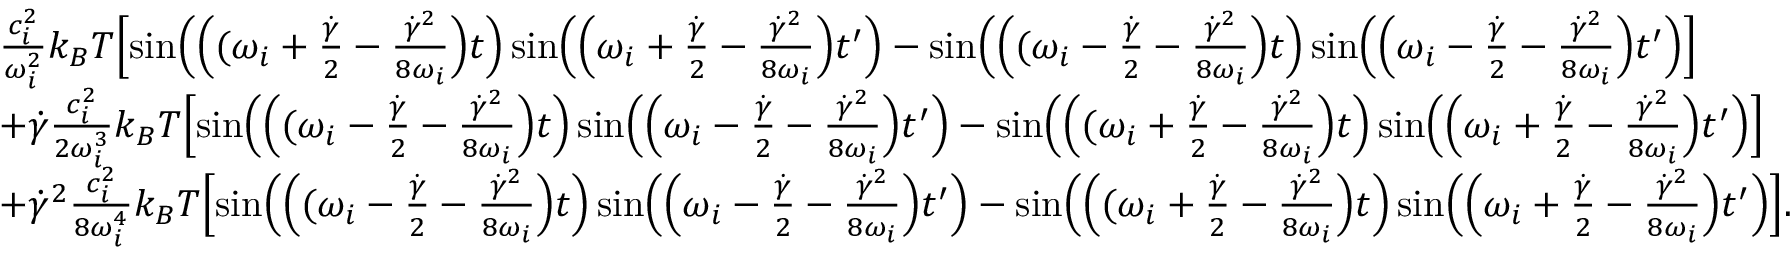<formula> <loc_0><loc_0><loc_500><loc_500>\begin{array} { r l } & { \frac { c _ { i } ^ { 2 } } { \omega _ { i } ^ { 2 } } k _ { B } T \left [ \sin \left ( \left ( ( \omega _ { i } + \frac { \dot { \gamma } } { 2 } - \frac { \dot { \gamma } ^ { 2 } } { 8 \omega _ { i } } \right ) t \right ) \sin \left ( \left ( \omega _ { i } + \frac { \dot { \gamma } } { 2 } - \frac { \dot { \gamma } ^ { 2 } } { 8 \omega _ { i } } \right ) t ^ { \prime } \right ) - \sin \left ( \left ( ( \omega _ { i } - \frac { \dot { \gamma } } { 2 } - \frac { \dot { \gamma } ^ { 2 } } { 8 \omega _ { i } } \right ) t \right ) \sin \left ( \left ( \omega _ { i } - \frac { \dot { \gamma } } { 2 } - \frac { \dot { \gamma } ^ { 2 } } { 8 \omega _ { i } } \right ) t ^ { \prime } \right ) \right ] } \\ & { + \dot { \gamma } \frac { c _ { i } ^ { 2 } } { 2 \omega _ { i } ^ { 3 } } k _ { B } T \left [ \sin \left ( \left ( ( \omega _ { i } - \frac { \dot { \gamma } } { 2 } - \frac { \dot { \gamma } ^ { 2 } } { 8 \omega _ { i } } \right ) t \right ) \sin \left ( \left ( \omega _ { i } - \frac { \dot { \gamma } } { 2 } - \frac { \dot { \gamma } ^ { 2 } } { 8 \omega _ { i } } \right ) t ^ { \prime } \right ) - \sin \left ( \left ( ( \omega _ { i } + \frac { \dot { \gamma } } { 2 } - \frac { \dot { \gamma } ^ { 2 } } { 8 \omega _ { i } } \right ) t \right ) \sin \left ( \left ( \omega _ { i } + \frac { \dot { \gamma } } { 2 } - \frac { \dot { \gamma } ^ { 2 } } { 8 \omega _ { i } } \right ) t ^ { \prime } \right ) \right ] } \\ & { + \dot { \gamma } ^ { 2 } \frac { c _ { i } ^ { 2 } } { 8 \omega _ { i } ^ { 4 } } k _ { B } T \left [ \sin \left ( \left ( ( \omega _ { i } - \frac { \dot { \gamma } } { 2 } - \frac { \dot { \gamma } ^ { 2 } } { 8 \omega _ { i } } \right ) t \right ) \sin \left ( \left ( \omega _ { i } - \frac { \dot { \gamma } } { 2 } - \frac { \dot { \gamma } ^ { 2 } } { 8 \omega _ { i } } \right ) t ^ { \prime } \right ) - \sin \left ( \left ( ( \omega _ { i } + \frac { \dot { \gamma } } { 2 } - \frac { \dot { \gamma } ^ { 2 } } { 8 \omega _ { i } } \right ) t \right ) \sin \left ( \left ( \omega _ { i } + \frac { \dot { \gamma } } { 2 } - \frac { \dot { \gamma } ^ { 2 } } { 8 \omega _ { i } } \right ) t ^ { \prime } \right ) \right ] . } \end{array}</formula> 